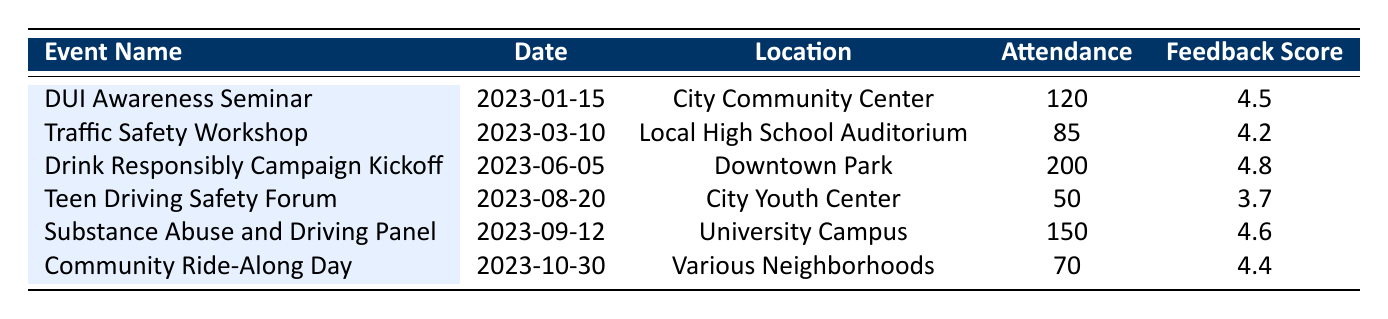What is the date of the DUI Awareness Seminar? The date for the DUI Awareness Seminar is listed directly in the table under the "Date" column. It shows as 2023-01-15.
Answer: 2023-01-15 Which event had the highest attendance? By reviewing the "Attendance" column in the table, the Drink Responsibly Campaign Kickoff shows the most significant number, with an attendance of 200.
Answer: Drink Responsibly Campaign Kickoff What is the average feedback score for all events? To find the average feedback score, sum all feedback scores (4.5 + 4.2 + 4.8 + 3.7 + 4.6 + 4.4 = 26.2) and divide by the number of events (6): 26.2 / 6 = 4.367 (approximately).
Answer: 4.37 Did the Teen Driving Safety Forum receive a feedback score above 4.0? The feedback score for the Teen Driving Safety Forum is 3.7, which is below 4.0, as per the data in the table.
Answer: No What is the total attendance across all events? To find the total attendance, sum the attendance of each event listed in the table (120 + 85 + 200 + 50 + 150 + 70 = 675).
Answer: 675 Which event had the lowest feedback score? Looking through the "Feedback Score" column, the Teen Driving Safety Forum has the lowest score at 3.7, highlighting it in comparison to other events.
Answer: Teen Driving Safety Forum How many attendees were at the Community Ride-Along Day? The "Attendance" column shows there were 70 attendees at the Community Ride-Along Day.
Answer: 70 Was the feedback score for the Substance Abuse and Driving Panel higher than that of the Traffic Safety Workshop? Checking the feedback scores, the Substance Abuse and Driving Panel has a score of 4.6 and the Traffic Safety Workshop has a score of 4.2. Since 4.6 is greater than 4.2, the answer is yes.
Answer: Yes What was the average attendance for events held in schools? Events held in schools are the Traffic Safety Workshop (85) and the Substance Abuse and Driving Panel (150). Their total attendance is (85 + 150 = 235), and dividing this by 2 gives an average of 117.5.
Answer: 117.5 